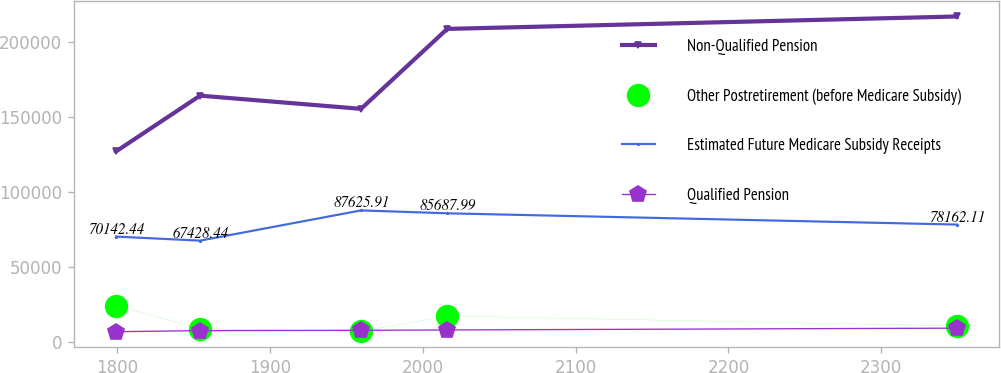Convert chart to OTSL. <chart><loc_0><loc_0><loc_500><loc_500><line_chart><ecel><fcel>Non-Qualified Pension<fcel>Other Postretirement (before Medicare Subsidy)<fcel>Estimated Future Medicare Subsidy Receipts<fcel>Qualified Pension<nl><fcel>1799.1<fcel>127003<fcel>24079.5<fcel>70142.4<fcel>6598.46<nl><fcel>1854.15<fcel>164300<fcel>8619.29<fcel>67428.4<fcel>7291.95<nl><fcel>1959.52<fcel>155479<fcel>6901.49<fcel>87625.9<fcel>7528.91<nl><fcel>2015.93<fcel>208884<fcel>17071.6<fcel>85688<fcel>7765.87<nl><fcel>2349.56<fcel>217173<fcel>10463.3<fcel>78162.1<fcel>8968.08<nl></chart> 